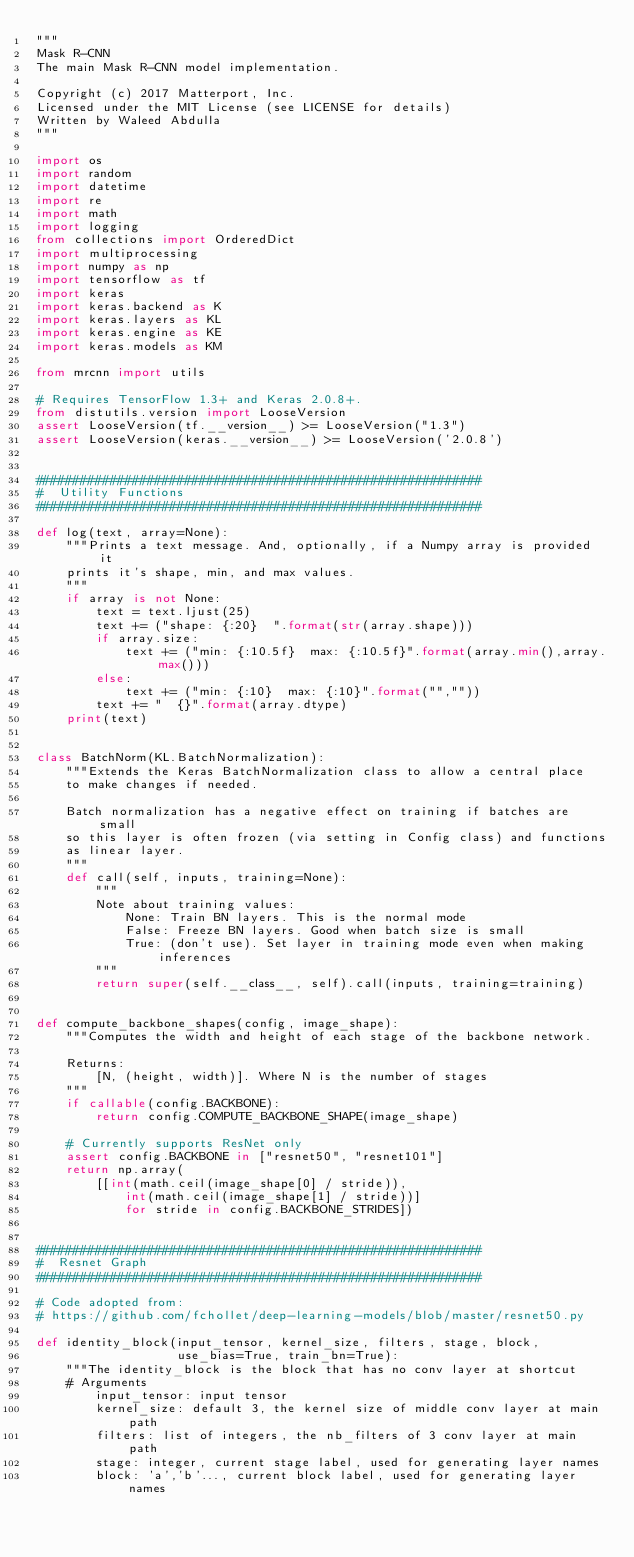Convert code to text. <code><loc_0><loc_0><loc_500><loc_500><_Python_>"""
Mask R-CNN
The main Mask R-CNN model implementation.

Copyright (c) 2017 Matterport, Inc.
Licensed under the MIT License (see LICENSE for details)
Written by Waleed Abdulla
"""

import os
import random
import datetime
import re
import math
import logging
from collections import OrderedDict
import multiprocessing
import numpy as np
import tensorflow as tf
import keras
import keras.backend as K
import keras.layers as KL
import keras.engine as KE
import keras.models as KM

from mrcnn import utils

# Requires TensorFlow 1.3+ and Keras 2.0.8+.
from distutils.version import LooseVersion
assert LooseVersion(tf.__version__) >= LooseVersion("1.3")
assert LooseVersion(keras.__version__) >= LooseVersion('2.0.8')


############################################################
#  Utility Functions
############################################################

def log(text, array=None):
    """Prints a text message. And, optionally, if a Numpy array is provided it
    prints it's shape, min, and max values.
    """
    if array is not None:
        text = text.ljust(25)
        text += ("shape: {:20}  ".format(str(array.shape)))
        if array.size:
            text += ("min: {:10.5f}  max: {:10.5f}".format(array.min(),array.max()))
        else:
            text += ("min: {:10}  max: {:10}".format("",""))
        text += "  {}".format(array.dtype)
    print(text)


class BatchNorm(KL.BatchNormalization):
    """Extends the Keras BatchNormalization class to allow a central place
    to make changes if needed.

    Batch normalization has a negative effect on training if batches are small
    so this layer is often frozen (via setting in Config class) and functions
    as linear layer.
    """
    def call(self, inputs, training=None):
        """
        Note about training values:
            None: Train BN layers. This is the normal mode
            False: Freeze BN layers. Good when batch size is small
            True: (don't use). Set layer in training mode even when making inferences
        """
        return super(self.__class__, self).call(inputs, training=training)


def compute_backbone_shapes(config, image_shape):
    """Computes the width and height of each stage of the backbone network.

    Returns:
        [N, (height, width)]. Where N is the number of stages
    """
    if callable(config.BACKBONE):
        return config.COMPUTE_BACKBONE_SHAPE(image_shape)

    # Currently supports ResNet only
    assert config.BACKBONE in ["resnet50", "resnet101"]
    return np.array(
        [[int(math.ceil(image_shape[0] / stride)),
            int(math.ceil(image_shape[1] / stride))]
            for stride in config.BACKBONE_STRIDES])


############################################################
#  Resnet Graph
############################################################

# Code adopted from:
# https://github.com/fchollet/deep-learning-models/blob/master/resnet50.py

def identity_block(input_tensor, kernel_size, filters, stage, block,
                   use_bias=True, train_bn=True):
    """The identity_block is the block that has no conv layer at shortcut
    # Arguments
        input_tensor: input tensor
        kernel_size: default 3, the kernel size of middle conv layer at main path
        filters: list of integers, the nb_filters of 3 conv layer at main path
        stage: integer, current stage label, used for generating layer names
        block: 'a','b'..., current block label, used for generating layer names</code> 